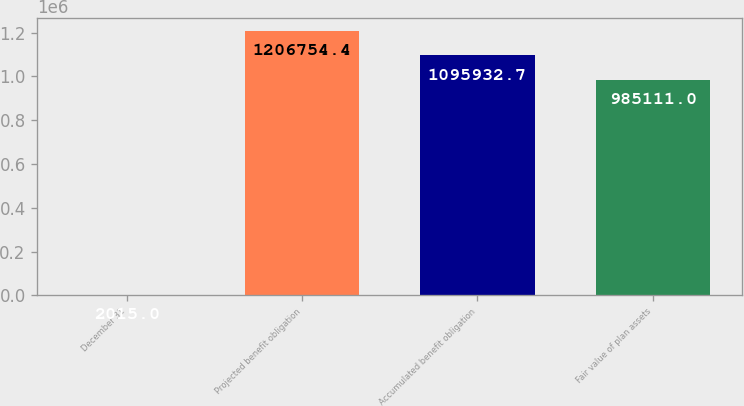<chart> <loc_0><loc_0><loc_500><loc_500><bar_chart><fcel>December 31<fcel>Projected benefit obligation<fcel>Accumulated benefit obligation<fcel>Fair value of plan assets<nl><fcel>2015<fcel>1.20675e+06<fcel>1.09593e+06<fcel>985111<nl></chart> 